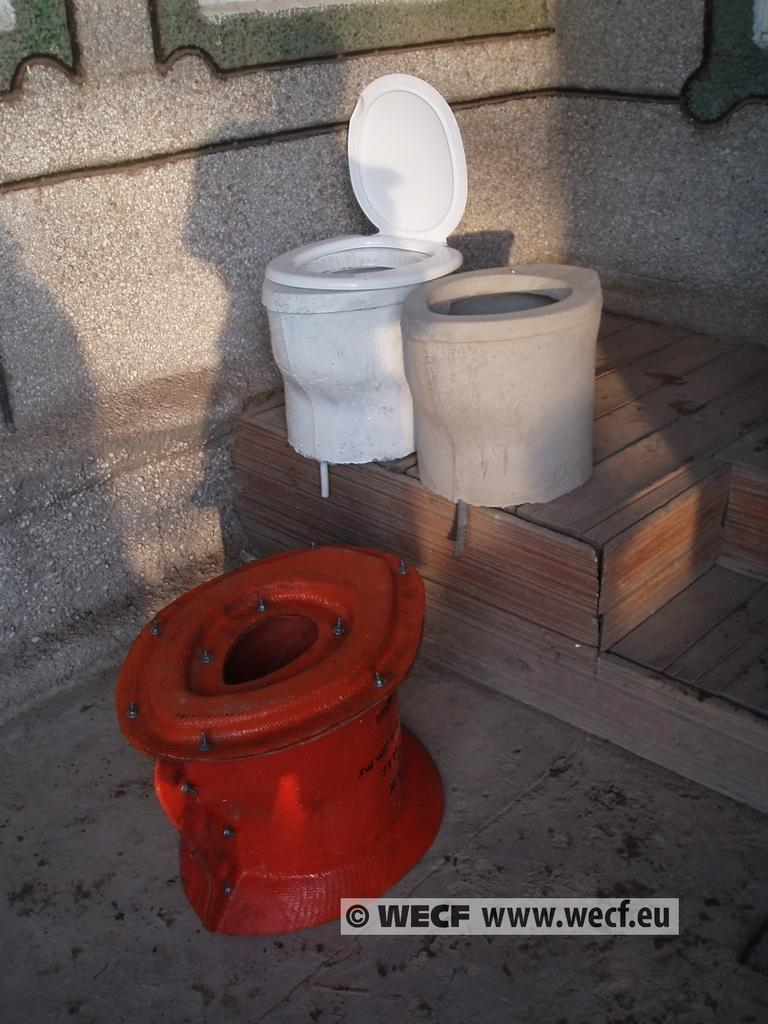<image>
Provide a brief description of the given image. A white , ceramic toilet is next to the cast it was made from on a photo with the website www.wecf.eu in the bottom, right hand corner. 